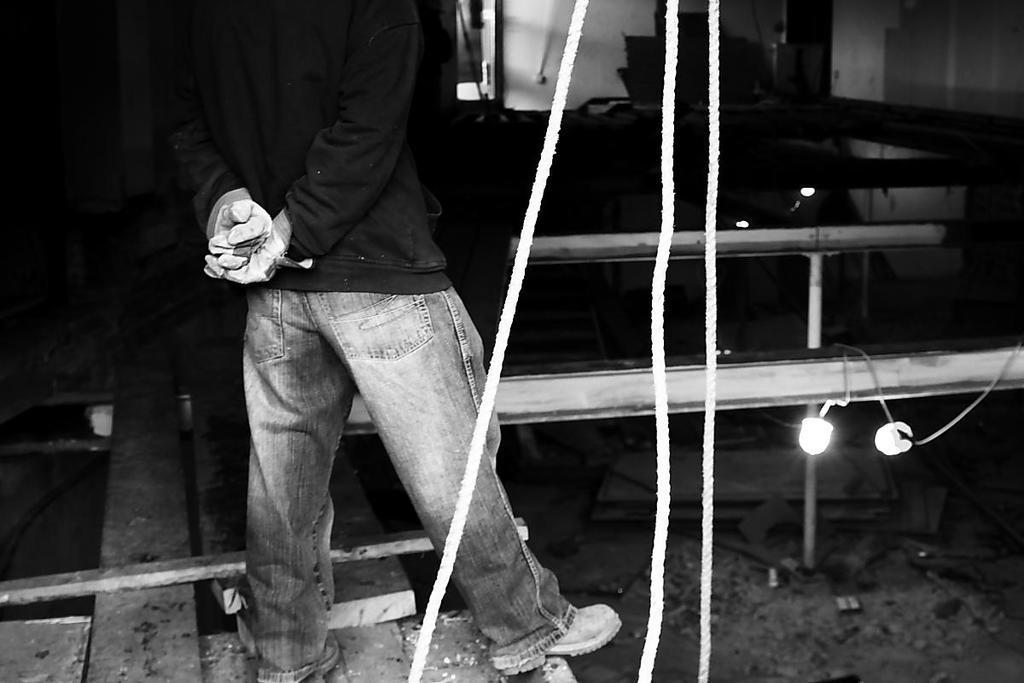Could you give a brief overview of what you see in this image? In this image we can see a person standing on the wooden plank, there are ropes and lights attached to the iron railing. 